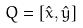Convert formula to latex. <formula><loc_0><loc_0><loc_500><loc_500>Q = [ \hat { x } , \hat { y } ]</formula> 